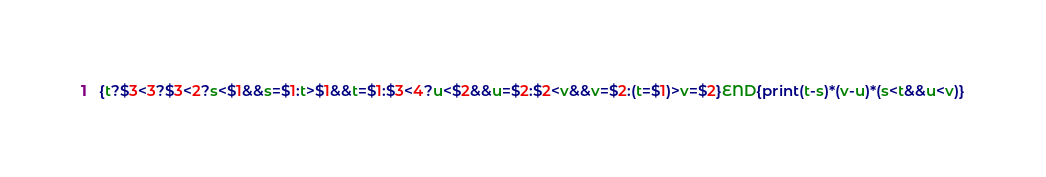<code> <loc_0><loc_0><loc_500><loc_500><_Awk_>{t?$3<3?$3<2?s<$1&&s=$1:t>$1&&t=$1:$3<4?u<$2&&u=$2:$2<v&&v=$2:(t=$1)>v=$2}END{print(t-s)*(v-u)*(s<t&&u<v)}</code> 